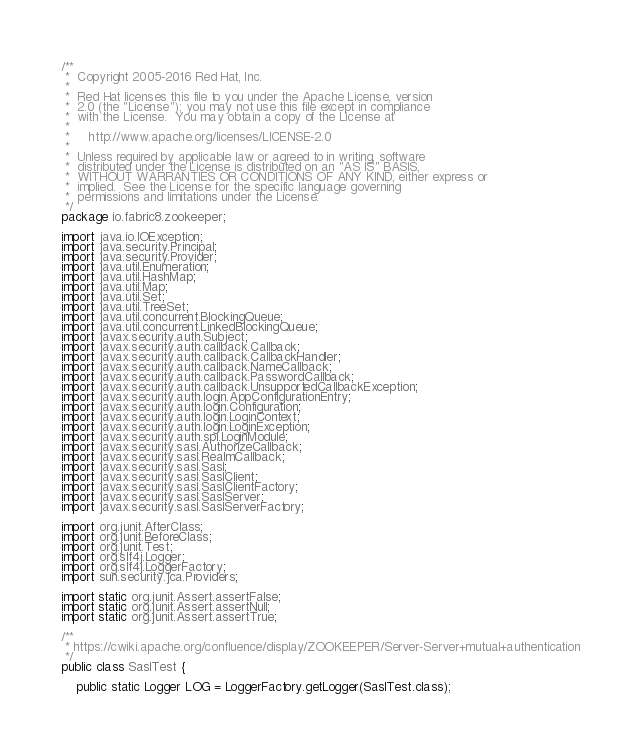<code> <loc_0><loc_0><loc_500><loc_500><_Java_>/**
 *  Copyright 2005-2016 Red Hat, Inc.
 *
 *  Red Hat licenses this file to you under the Apache License, version
 *  2.0 (the "License"); you may not use this file except in compliance
 *  with the License.  You may obtain a copy of the License at
 *
 *     http://www.apache.org/licenses/LICENSE-2.0
 *
 *  Unless required by applicable law or agreed to in writing, software
 *  distributed under the License is distributed on an "AS IS" BASIS,
 *  WITHOUT WARRANTIES OR CONDITIONS OF ANY KIND, either express or
 *  implied.  See the License for the specific language governing
 *  permissions and limitations under the License.
 */
package io.fabric8.zookeeper;

import java.io.IOException;
import java.security.Principal;
import java.security.Provider;
import java.util.Enumeration;
import java.util.HashMap;
import java.util.Map;
import java.util.Set;
import java.util.TreeSet;
import java.util.concurrent.BlockingQueue;
import java.util.concurrent.LinkedBlockingQueue;
import javax.security.auth.Subject;
import javax.security.auth.callback.Callback;
import javax.security.auth.callback.CallbackHandler;
import javax.security.auth.callback.NameCallback;
import javax.security.auth.callback.PasswordCallback;
import javax.security.auth.callback.UnsupportedCallbackException;
import javax.security.auth.login.AppConfigurationEntry;
import javax.security.auth.login.Configuration;
import javax.security.auth.login.LoginContext;
import javax.security.auth.login.LoginException;
import javax.security.auth.spi.LoginModule;
import javax.security.sasl.AuthorizeCallback;
import javax.security.sasl.RealmCallback;
import javax.security.sasl.Sasl;
import javax.security.sasl.SaslClient;
import javax.security.sasl.SaslClientFactory;
import javax.security.sasl.SaslServer;
import javax.security.sasl.SaslServerFactory;

import org.junit.AfterClass;
import org.junit.BeforeClass;
import org.junit.Test;
import org.slf4j.Logger;
import org.slf4j.LoggerFactory;
import sun.security.jca.Providers;

import static org.junit.Assert.assertFalse;
import static org.junit.Assert.assertNull;
import static org.junit.Assert.assertTrue;

/**
 * https://cwiki.apache.org/confluence/display/ZOOKEEPER/Server-Server+mutual+authentication
 */
public class SaslTest {

    public static Logger LOG = LoggerFactory.getLogger(SaslTest.class);
</code> 